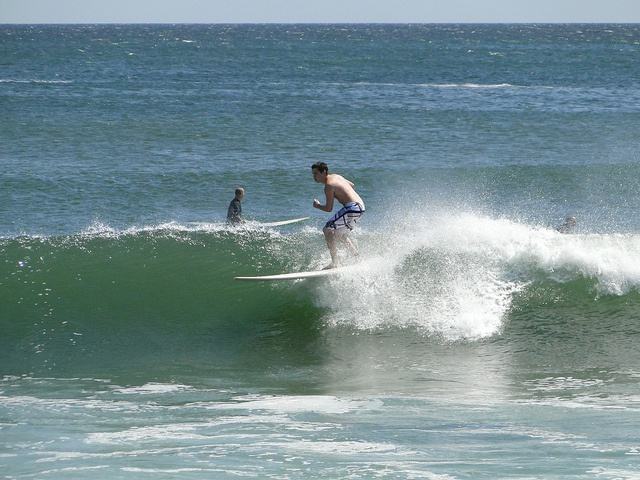Describe the objects in this image and their specific colors. I can see people in darkgray, gray, lightgray, and black tones, surfboard in darkgray, white, gray, and darkgreen tones, people in darkgray, gray, black, and darkblue tones, people in darkgray and gray tones, and surfboard in darkgray, lightgray, and gray tones in this image. 